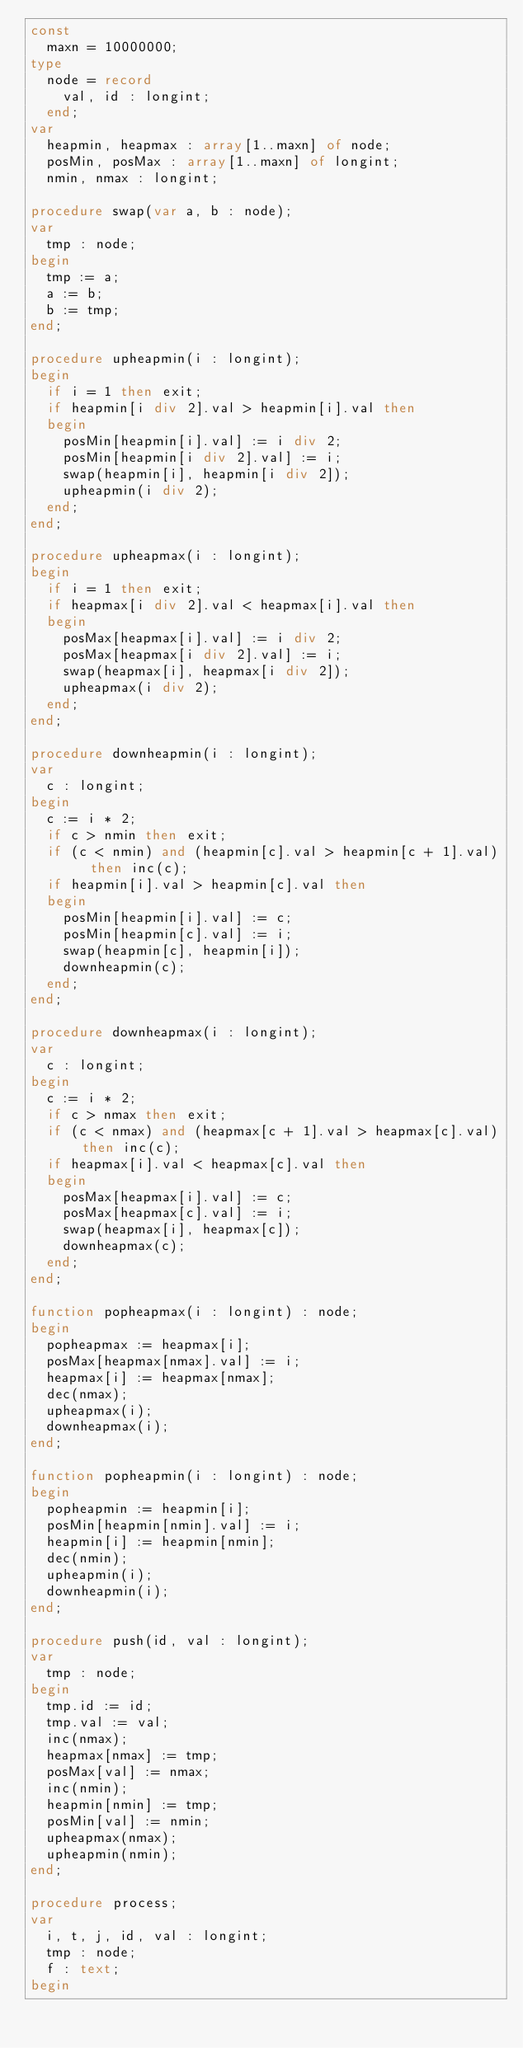<code> <loc_0><loc_0><loc_500><loc_500><_Pascal_>const
  maxn = 10000000;
type
  node = record
    val, id : longint;
  end;
var
  heapmin, heapmax : array[1..maxn] of node;
  posMin, posMax : array[1..maxn] of longint;
  nmin, nmax : longint;

procedure swap(var a, b : node);
var
  tmp : node;
begin
  tmp := a;
  a := b;
  b := tmp;
end;

procedure upheapmin(i : longint);
begin
  if i = 1 then exit;
  if heapmin[i div 2].val > heapmin[i].val then
  begin
    posMin[heapmin[i].val] := i div 2;
    posMin[heapmin[i div 2].val] := i;
    swap(heapmin[i], heapmin[i div 2]);
    upheapmin(i div 2);
  end;
end;

procedure upheapmax(i : longint);
begin
  if i = 1 then exit;
  if heapmax[i div 2].val < heapmax[i].val then
  begin
    posMax[heapmax[i].val] := i div 2;
    posMax[heapmax[i div 2].val] := i;
    swap(heapmax[i], heapmax[i div 2]);
    upheapmax(i div 2);
  end;
end;

procedure downheapmin(i : longint);
var
  c : longint;
begin
  c := i * 2;
  if c > nmin then exit;
  if (c < nmin) and (heapmin[c].val > heapmin[c + 1].val)  then inc(c);
  if heapmin[i].val > heapmin[c].val then
  begin
    posMin[heapmin[i].val] := c;
    posMin[heapmin[c].val] := i;
    swap(heapmin[c], heapmin[i]);
    downheapmin(c);
  end;
end;

procedure downheapmax(i : longint);
var
  c : longint;
begin
  c := i * 2;
  if c > nmax then exit;
  if (c < nmax) and (heapmax[c + 1].val > heapmax[c].val) then inc(c);
  if heapmax[i].val < heapmax[c].val then
  begin
    posMax[heapmax[i].val] := c;
    posMax[heapmax[c].val] := i;
    swap(heapmax[i], heapmax[c]);
    downheapmax(c);
  end;
end;

function popheapmax(i : longint) : node;
begin
  popheapmax := heapmax[i];
  posMax[heapmax[nmax].val] := i;
  heapmax[i] := heapmax[nmax];
  dec(nmax);
  upheapmax(i);
  downheapmax(i);
end;

function popheapmin(i : longint) : node;
begin
  popheapmin := heapmin[i];
  posMin[heapmin[nmin].val] := i;
  heapmin[i] := heapmin[nmin];
  dec(nmin);
  upheapmin(i);
  downheapmin(i);
end;

procedure push(id, val : longint);
var
  tmp : node;
begin
  tmp.id := id;
  tmp.val := val;
  inc(nmax);
  heapmax[nmax] := tmp;
  posMax[val] := nmax;
  inc(nmin);
  heapmin[nmin] := tmp;
  posMin[val] := nmin;
  upheapmax(nmax);
  upheapmin(nmin);
end;

procedure process;
var
  i, t, j, id, val : longint;
  tmp : node;
  f : text;
begin</code> 